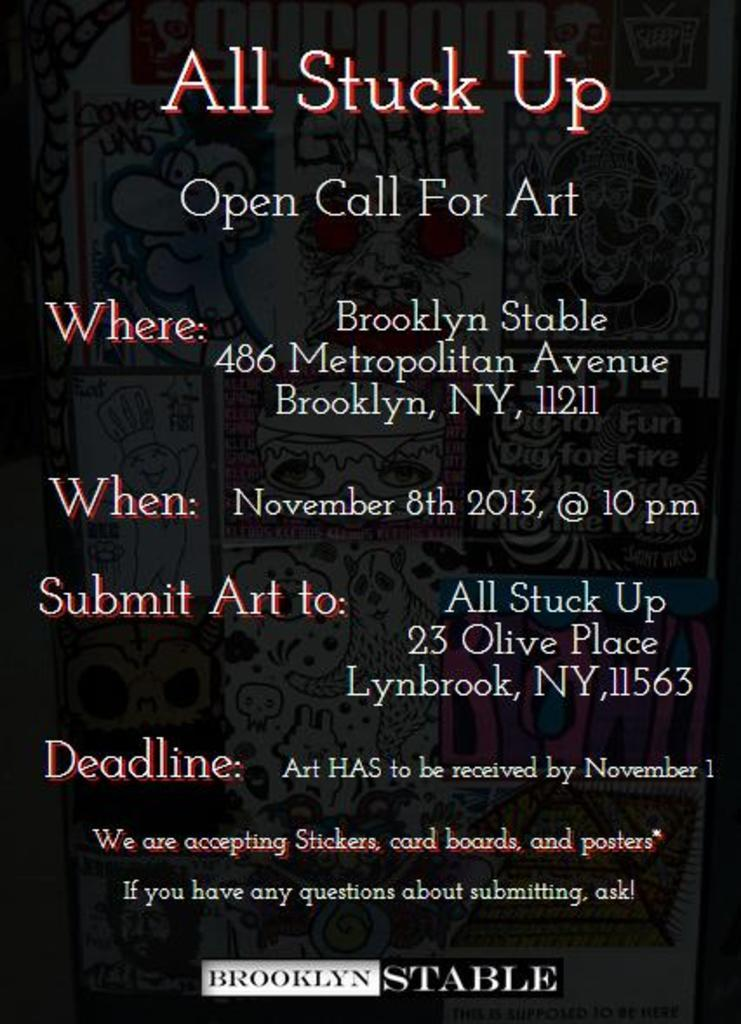<image>
Relay a brief, clear account of the picture shown. a black advertisement for All stuck UP in Brooklyn, NY 